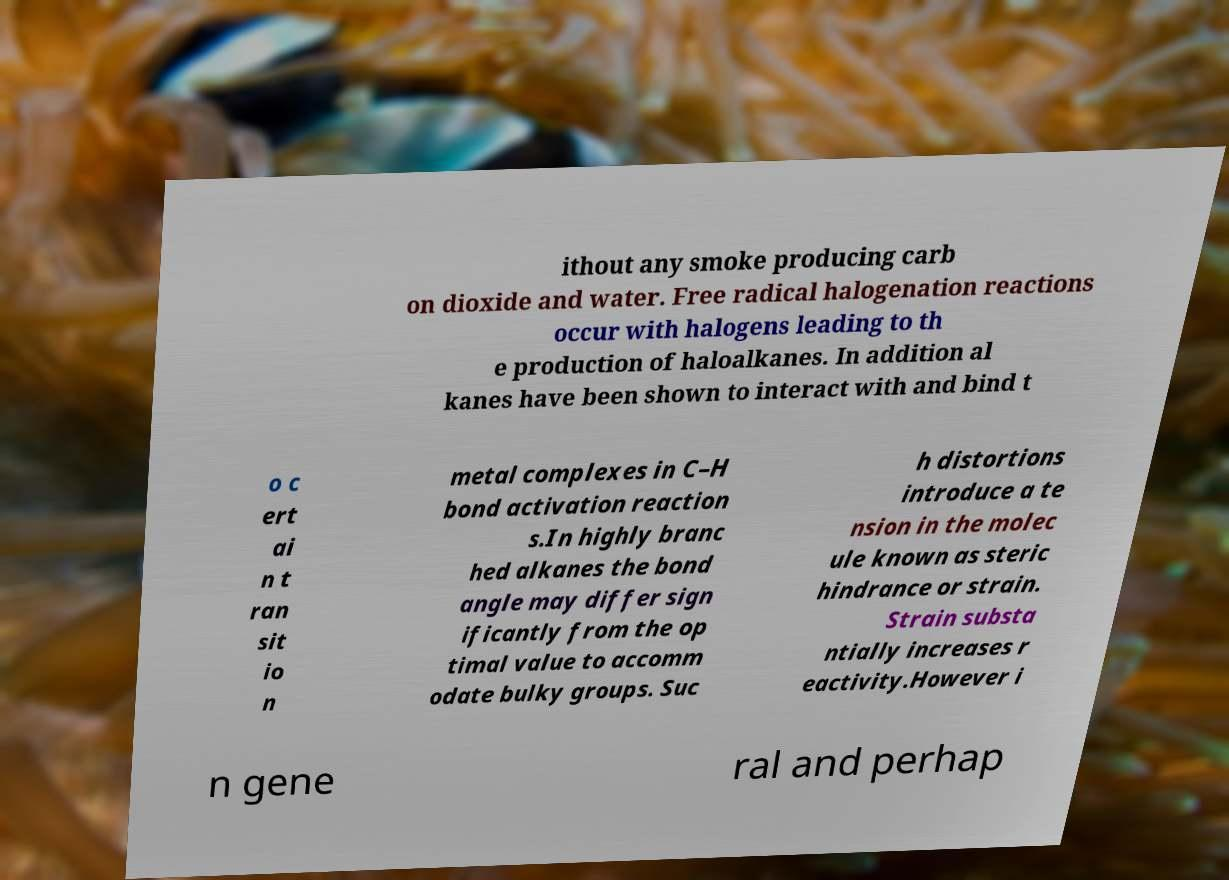Please identify and transcribe the text found in this image. ithout any smoke producing carb on dioxide and water. Free radical halogenation reactions occur with halogens leading to th e production of haloalkanes. In addition al kanes have been shown to interact with and bind t o c ert ai n t ran sit io n metal complexes in C–H bond activation reaction s.In highly branc hed alkanes the bond angle may differ sign ificantly from the op timal value to accomm odate bulky groups. Suc h distortions introduce a te nsion in the molec ule known as steric hindrance or strain. Strain substa ntially increases r eactivity.However i n gene ral and perhap 